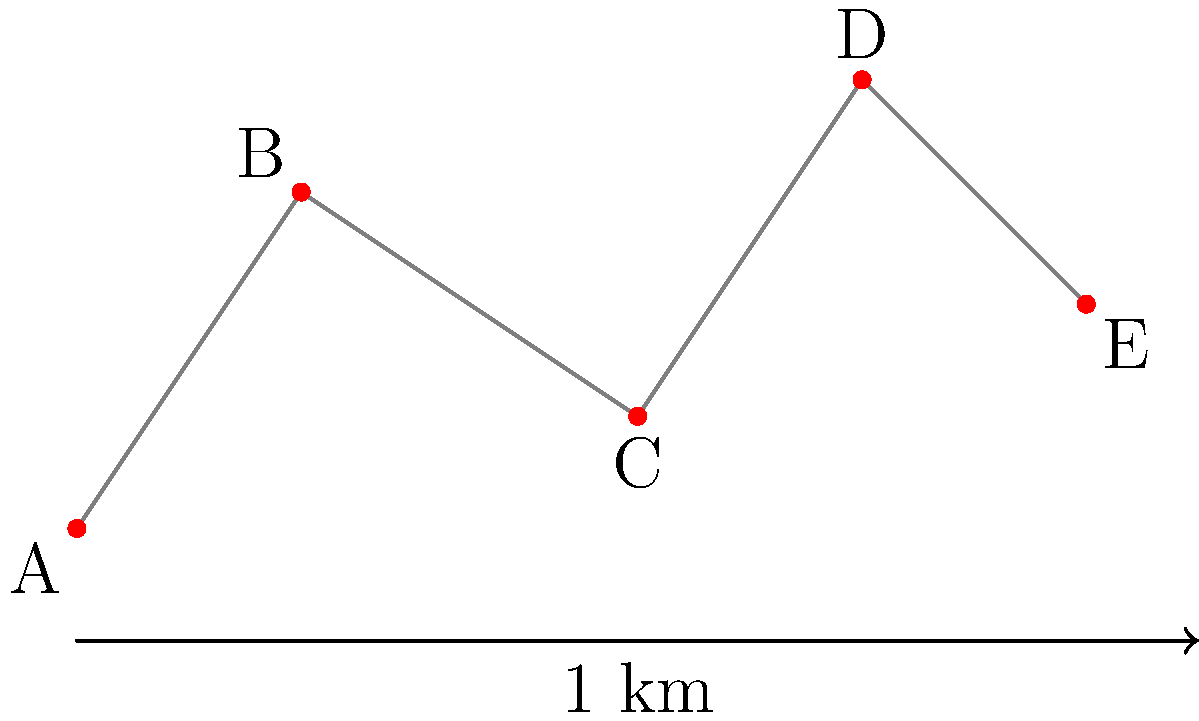As a tour guide, you're planning the most efficient route to visit all attractions on the map. Starting from point A and ending at point E, what is the total distance traveled if you visit the attractions in the optimal order? To find the most efficient route, we need to calculate the distances between each pair of attractions and determine the shortest path that visits all points.

Step 1: Calculate distances between adjacent attractions:
A to B: $\sqrt{2^2 + 3^2} = \sqrt{13} \approx 3.61$ km
B to C: $\sqrt{3^2 + (-2)^2} = \sqrt{13} \approx 3.61$ km
C to D: $\sqrt{2^2 + 3^2} = \sqrt{13} \approx 3.61$ km
D to E: $\sqrt{2^2 + (-2)^2} = \sqrt{8} \approx 2.83$ km

Step 2: Consider possible routes:
A → B → C → D → E
A → B → D → C → E
A → C → B → D → E
A → C → D → B → E

Step 3: Calculate total distances for each route:
A → B → C → D → E: 3.61 + 3.61 + 3.61 + 2.83 = 13.66 km
A → B → D → C → E: 3.61 + 5 + 3.61 + 4.47 = 16.69 km
A → C → B → D → E: 5.10 + 3.61 + 3.61 + 2.83 = 15.15 km
A → C → D → B → E: 5.10 + 3.61 + 5 + 2.24 = 15.95 km

Step 4: Identify the shortest route:
The shortest route is A → B → C → D → E, with a total distance of 13.66 km.
Answer: 13.66 km 